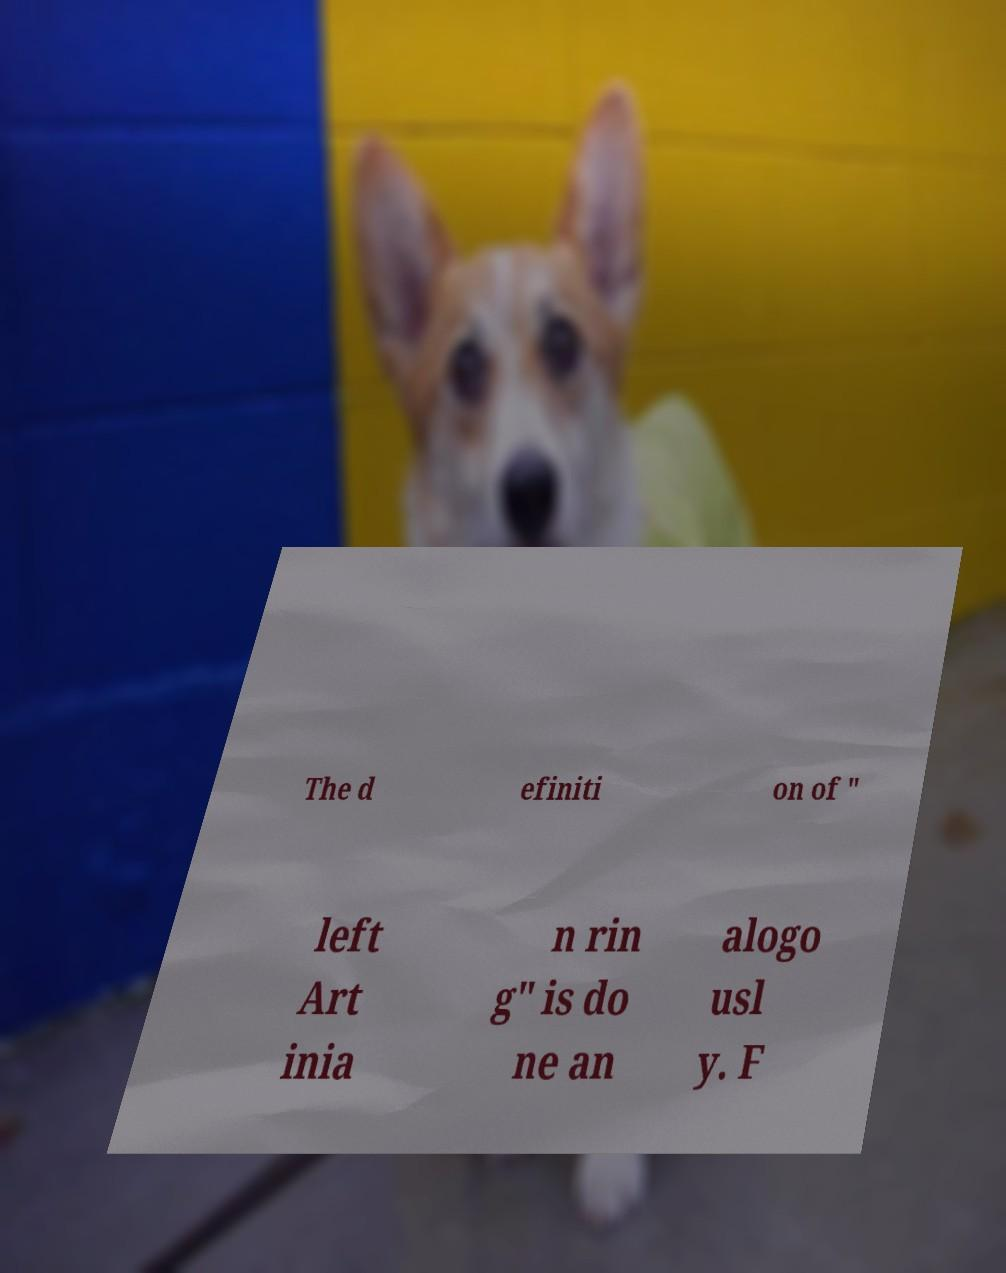For documentation purposes, I need the text within this image transcribed. Could you provide that? The d efiniti on of " left Art inia n rin g" is do ne an alogo usl y. F 